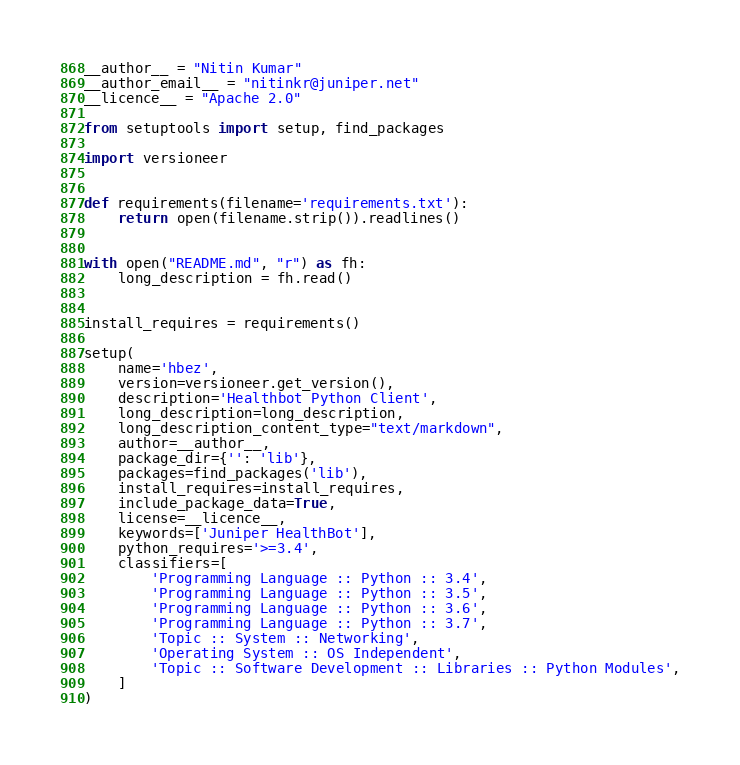<code> <loc_0><loc_0><loc_500><loc_500><_Python_>__author__ = "Nitin Kumar"
__author_email__ = "nitinkr@juniper.net"
__licence__ = "Apache 2.0"

from setuptools import setup, find_packages

import versioneer


def requirements(filename='requirements.txt'):
    return open(filename.strip()).readlines()


with open("README.md", "r") as fh:
    long_description = fh.read()


install_requires = requirements()

setup(
    name='hbez',
    version=versioneer.get_version(),
    description='Healthbot Python Client',
    long_description=long_description,
    long_description_content_type="text/markdown",
    author=__author__,
    package_dir={'': 'lib'},
    packages=find_packages('lib'),
    install_requires=install_requires,
    include_package_data=True,
    license=__licence__,
    keywords=['Juniper HealthBot'],
    python_requires='>=3.4',
    classifiers=[
        'Programming Language :: Python :: 3.4',
        'Programming Language :: Python :: 3.5',
        'Programming Language :: Python :: 3.6',
        'Programming Language :: Python :: 3.7',
        'Topic :: System :: Networking',
        'Operating System :: OS Independent',
        'Topic :: Software Development :: Libraries :: Python Modules',
    ]
)
</code> 